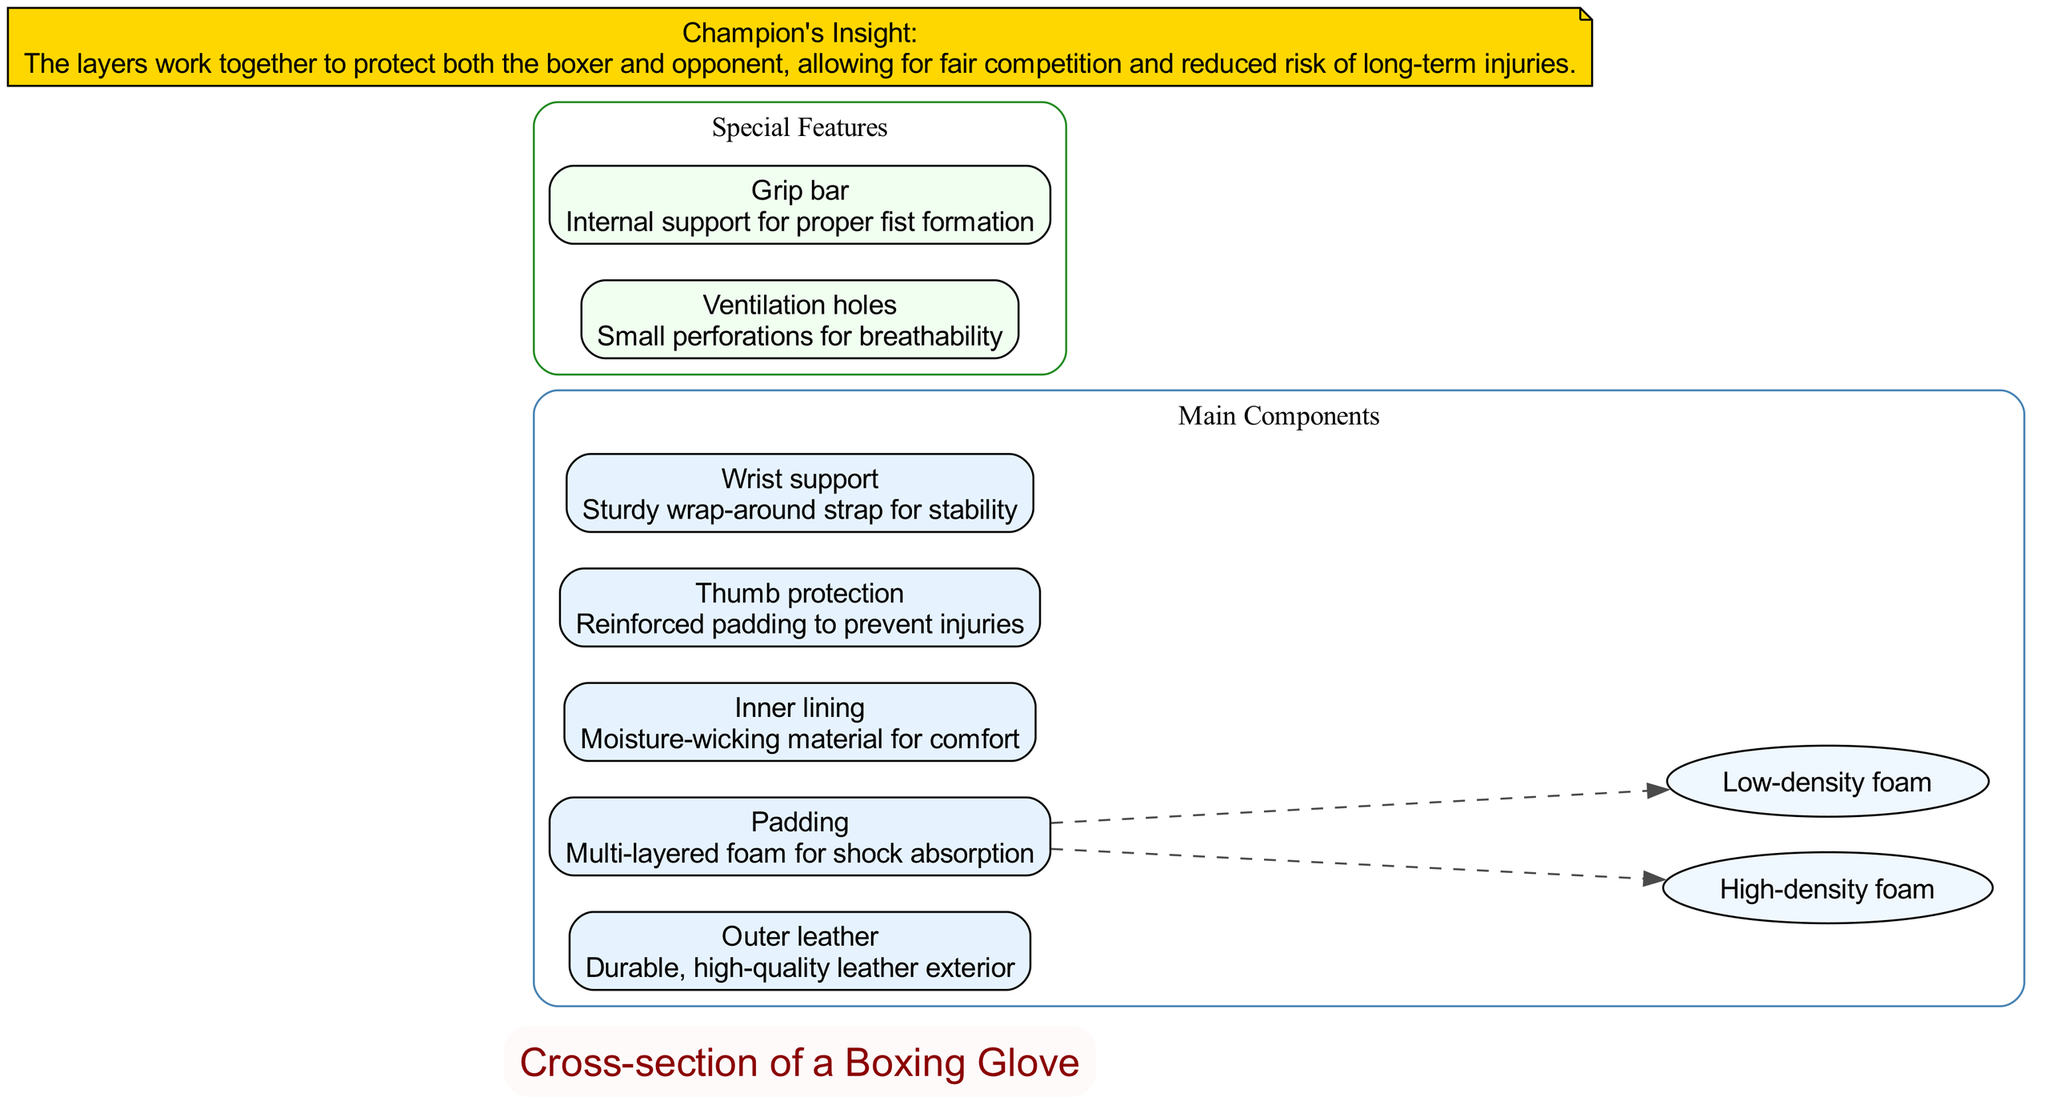What is the outermost layer of the boxing glove? The diagram shows that the outermost layer is labeled as "Outer leather," which is positioned at the top as the first component listed under main components.
Answer: Outer leather How many main components are there in the boxing glove? By counting the items listed under the "Main Components" section in the diagram, we identify five distinct elements: outer leather, padding, inner lining, thumb protection, and wrist support.
Answer: 5 What is the purpose of the padding layer? The diagram specifies that the padding serves as "Multi-layered foam for shock absorption," indicating its primary function succinctly under the corresponding component label.
Answer: Shock absorption Which component provides moisture-wicking for comfort? In the diagram, the "Inner lining" component is specifically described as "Moisture-wicking material for comfort," making it clear that this layer addresses moisture management to enhance user comfort.
Answer: Inner lining What special feature has small perforations for breathability? The diagram highlights "Ventilation holes" under Special Features and describes that they provide small perforations for breathability, directly linking the feature with its function.
Answer: Ventilation holes How does the champion view the layers of the boxing glove? The diagram features a separate node for the Champion's Insight, which states, "The layers work together to protect both the boxer and opponent, allowing for fair competition and reduced risk of long-term injuries," summarizing the champion's perspective on the glove's design.
Answer: Protect Which component is noted for facilitating proper fist formation? Under the Special Features section, "Grip bar" is indicated as the component that provides internal support for proper fist formation, which relates directly to its functionality as described in the diagram.
Answer: Grip bar How many sub-components are included in the padding? Observing the diagram, the padding section has two identified sub-components: high-density foam and low-density foam, which can be counted directly from the text under padding.
Answer: 2 What type of strap is used for wrist support? The diagram states that the "Wrist support" is a "Sturdy wrap-around strap for stability," indicating the type and purpose of this component succinctly.
Answer: Wrap-around strap 